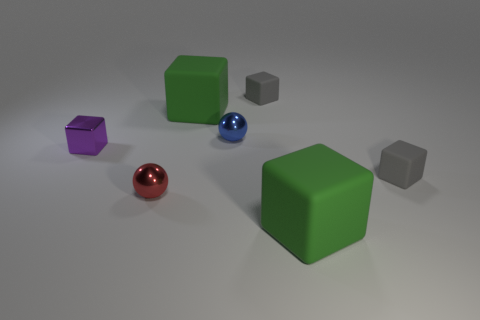Do the blue thing and the small cube that is left of the tiny blue metallic object have the same material?
Provide a short and direct response. Yes. Is the shape of the gray matte object that is behind the blue sphere the same as  the tiny red object?
Your answer should be very brief. No. There is a blue object that is the same shape as the small red metal thing; what is it made of?
Provide a succinct answer. Metal. Do the tiny blue metallic object and the gray object that is behind the blue metal ball have the same shape?
Offer a very short reply. No. There is a small thing that is in front of the tiny purple metallic cube and right of the tiny red object; what is its color?
Provide a succinct answer. Gray. Is there a small red block?
Offer a terse response. No. Is the number of tiny blocks in front of the small purple metallic object the same as the number of big green shiny things?
Offer a very short reply. No. What number of other objects are there of the same shape as the blue object?
Your answer should be compact. 1. The purple thing is what shape?
Ensure brevity in your answer.  Cube. Is the material of the tiny purple object the same as the tiny red sphere?
Keep it short and to the point. Yes. 